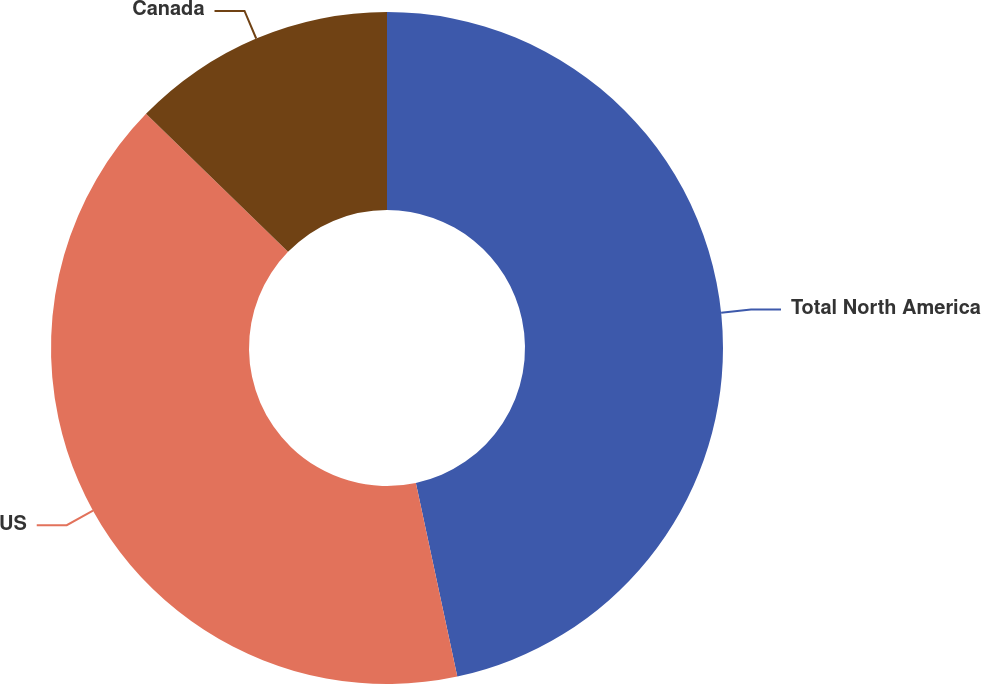Convert chart. <chart><loc_0><loc_0><loc_500><loc_500><pie_chart><fcel>Total North America<fcel>US<fcel>Canada<nl><fcel>46.65%<fcel>40.63%<fcel>12.73%<nl></chart> 